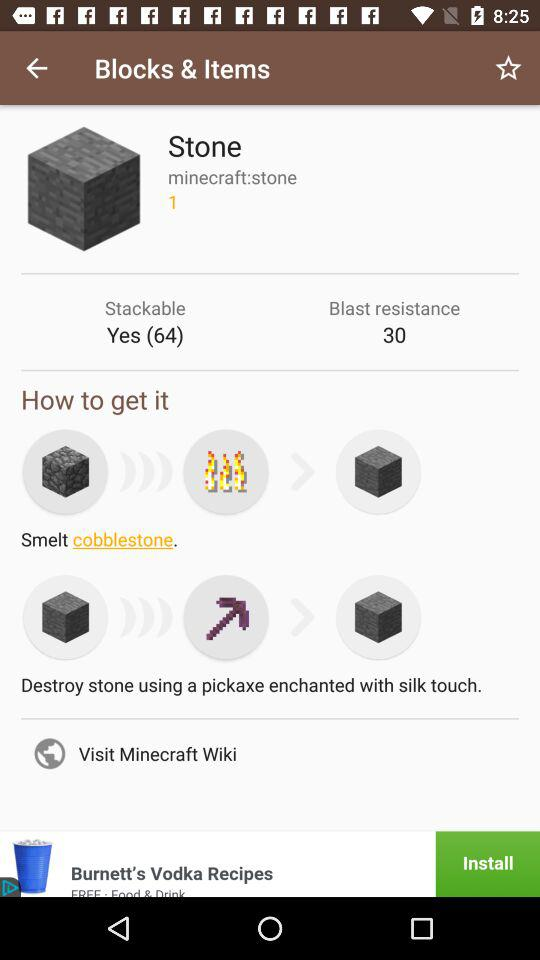What type of stone is mentioned? The mentioned type of stone is "cobblestone". 